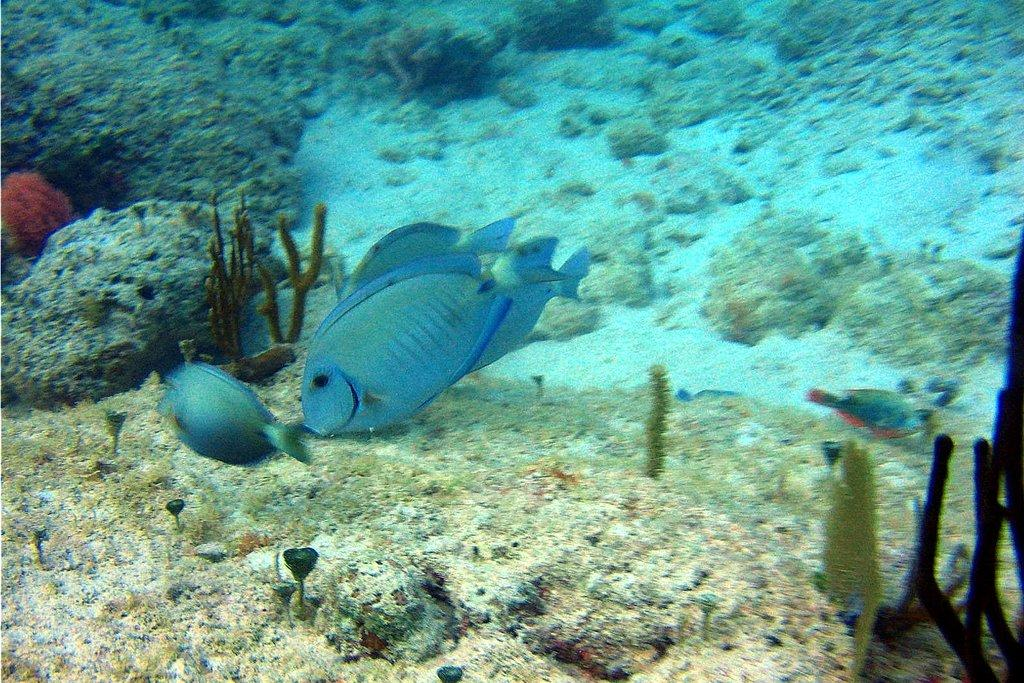What type of environment is shown in the image? The image depicts an underground surface of water. What type of aquatic life can be seen in the image? There are small fishes in the image. What other types of vegetation are visible in the image? There are other plants visible in the image. What type of beam is holding up the ceiling in the image? There is no ceiling or beam present in the image, as it depicts an underground surface of water. 